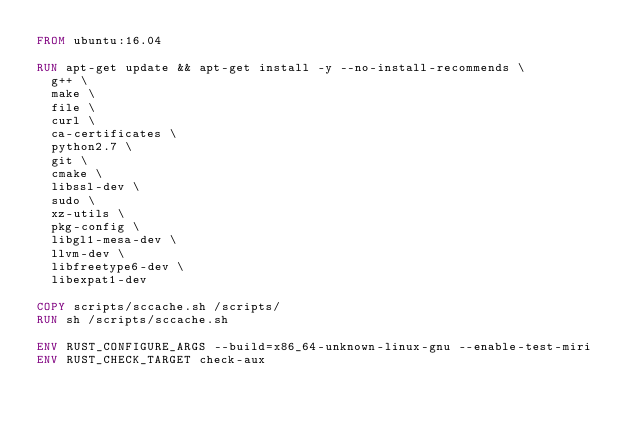Convert code to text. <code><loc_0><loc_0><loc_500><loc_500><_Dockerfile_>FROM ubuntu:16.04

RUN apt-get update && apt-get install -y --no-install-recommends \
  g++ \
  make \
  file \
  curl \
  ca-certificates \
  python2.7 \
  git \
  cmake \
  libssl-dev \
  sudo \
  xz-utils \
  pkg-config \
  libgl1-mesa-dev \
  llvm-dev \
  libfreetype6-dev \
  libexpat1-dev

COPY scripts/sccache.sh /scripts/
RUN sh /scripts/sccache.sh

ENV RUST_CONFIGURE_ARGS --build=x86_64-unknown-linux-gnu --enable-test-miri
ENV RUST_CHECK_TARGET check-aux
</code> 